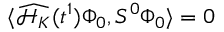<formula> <loc_0><loc_0><loc_500><loc_500>\langle \widehat { \mathcal { H } _ { K } } ( t ^ { 1 } ) \Phi _ { 0 } , S ^ { 0 } \Phi _ { 0 } \rangle = 0</formula> 